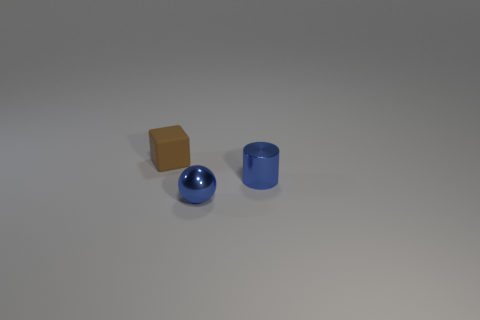What number of other objects are the same color as the small ball?
Provide a short and direct response. 1. There is a blue object right of the blue metal sphere; is it the same size as the brown block to the left of the small blue cylinder?
Provide a succinct answer. Yes. Is the number of tiny cylinders that are on the left side of the cube the same as the number of metallic objects in front of the blue metallic cylinder?
Offer a terse response. No. Is there any other thing that has the same material as the tiny brown cube?
Offer a very short reply. No. There is a brown rubber block; is it the same size as the thing right of the tiny ball?
Give a very brief answer. Yes. What material is the object behind the blue metallic object that is right of the blue ball?
Ensure brevity in your answer.  Rubber. Is the number of brown things left of the brown object the same as the number of small brown rubber balls?
Your answer should be very brief. Yes. There is a object that is both right of the block and behind the small blue metallic sphere; what is its size?
Ensure brevity in your answer.  Small. What is the color of the small thing behind the small blue thing that is on the right side of the tiny shiny ball?
Your response must be concise. Brown. How many purple objects are either large matte cubes or tiny things?
Ensure brevity in your answer.  0. 